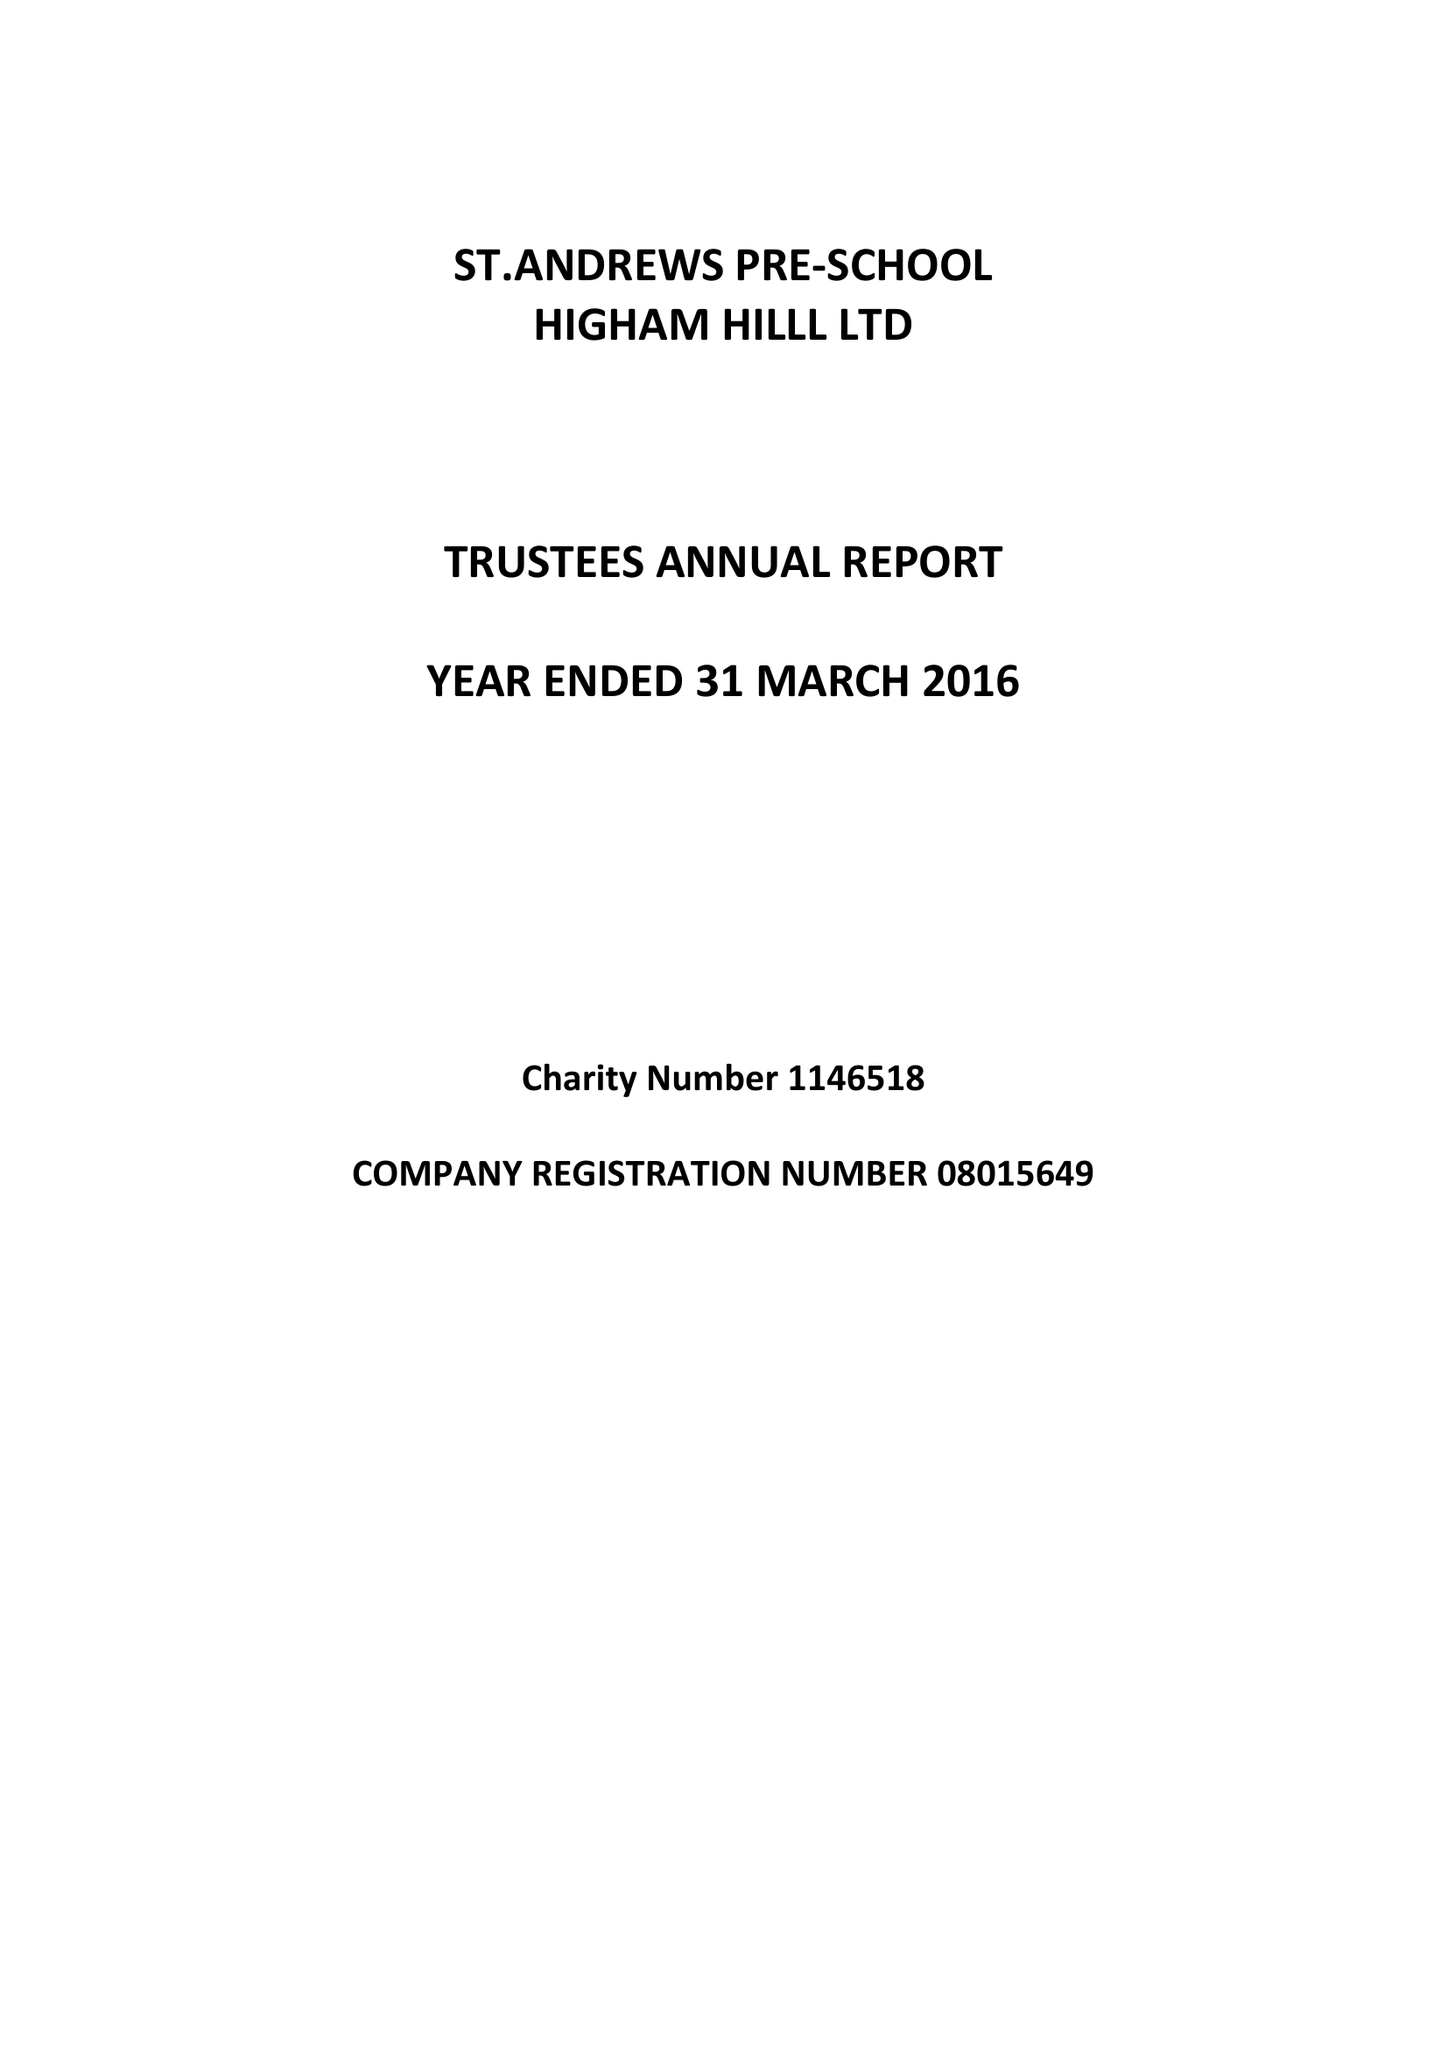What is the value for the spending_annually_in_british_pounds?
Answer the question using a single word or phrase. 111717.00 